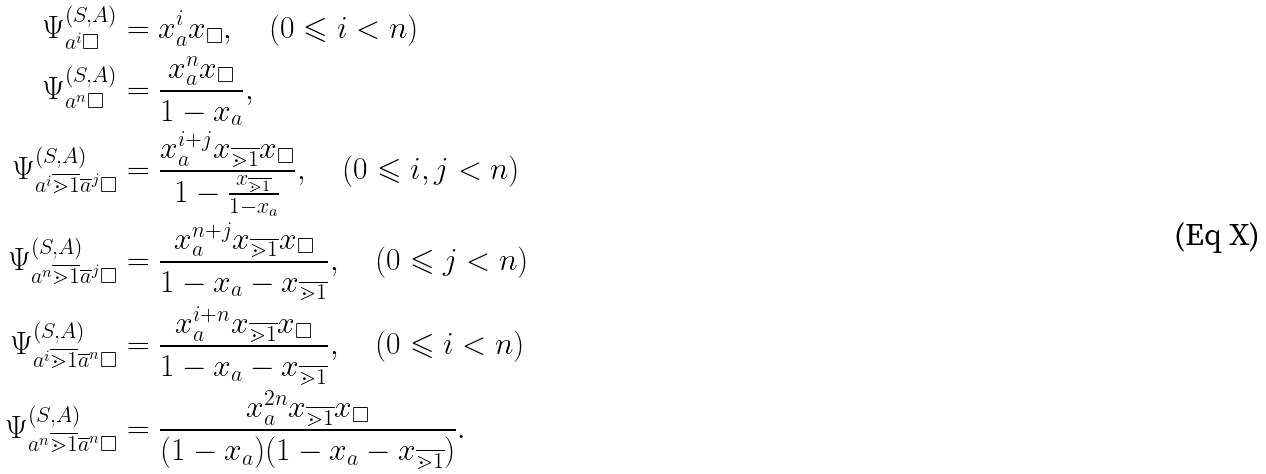Convert formula to latex. <formula><loc_0><loc_0><loc_500><loc_500>\Psi ^ { ( S , A ) } _ { a ^ { i } \square } & = x _ { a } ^ { i } x _ { \square } , \quad ( 0 \leqslant i < n ) \\ \Psi ^ { ( S , A ) } _ { a ^ { n } \square } & = \frac { x _ { a } ^ { n } x _ { \square } } { 1 - x _ { a } } , \\ \Psi ^ { ( S , A ) } _ { a ^ { i } \overline { \mathbb { m } { 1 } } \overline { a } ^ { j } \square } & = \frac { x _ { a } ^ { i + j } x _ { \overline { \mathbb { m } { 1 } } } x _ { \square } } { 1 - \frac { x _ { \overline { \mathbb { m } { 1 } } } } { 1 - x _ { a } } } , \quad ( 0 \leqslant i , j < n ) \\ \Psi ^ { ( S , A ) } _ { a ^ { n } \overline { \mathbb { m } { 1 } } \overline { a } ^ { j } \square } & = \frac { x _ { a } ^ { n + j } x _ { \overline { \mathbb { m } { 1 } } } x _ { \square } } { 1 - x _ { a } - x _ { \overline { \mathbb { m } { 1 } } } } , \quad ( 0 \leqslant j < n ) \\ \Psi ^ { ( S , A ) } _ { a ^ { i } \overline { \mathbb { m } { 1 } } \overline { a } ^ { n } \square } & = \frac { x _ { a } ^ { i + n } x _ { \overline { \mathbb { m } { 1 } } } x _ { \square } } { 1 - x _ { a } - x _ { \overline { \mathbb { m } { 1 } } } } , \quad ( 0 \leqslant i < n ) \\ \Psi ^ { ( S , A ) } _ { a ^ { n } \overline { \mathbb { m } { 1 } } \overline { a } ^ { n } \square } & = \frac { x _ { a } ^ { 2 n } x _ { \overline { \mathbb { m } { 1 } } } x _ { \square } } { ( 1 - x _ { a } ) ( 1 - x _ { a } - x _ { \overline { \mathbb { m } { 1 } } } ) } .</formula> 